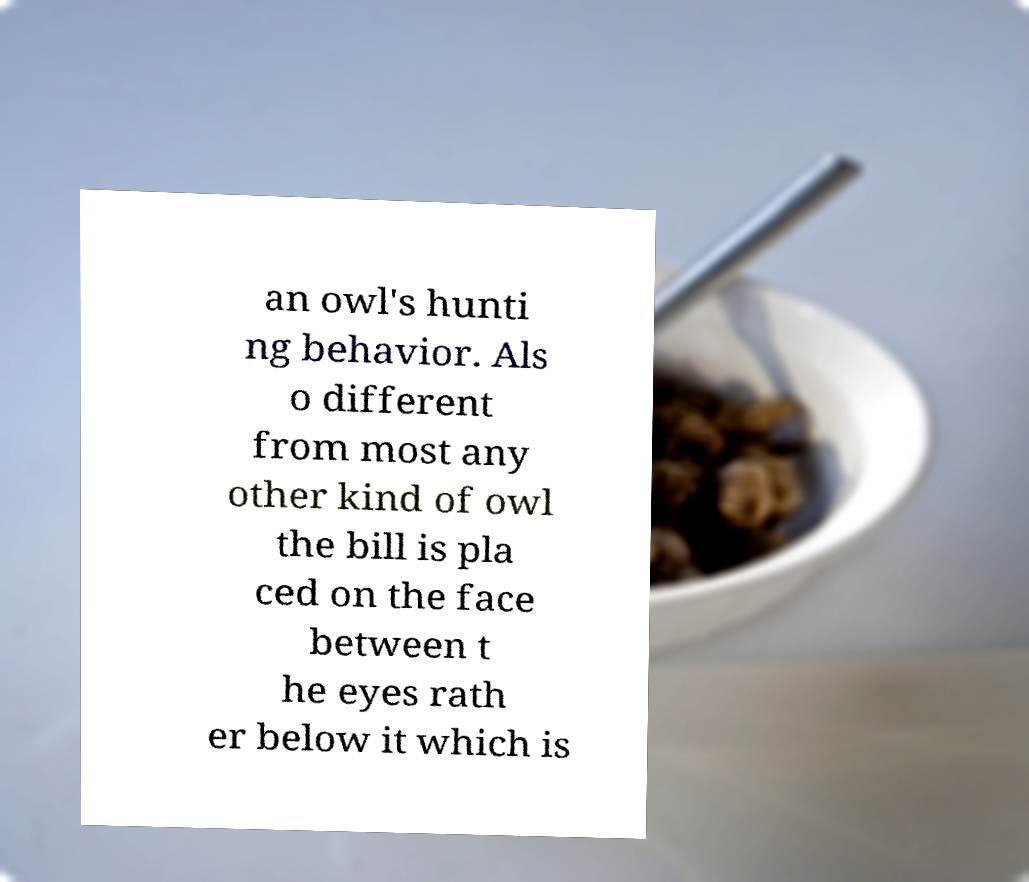Please read and relay the text visible in this image. What does it say? an owl's hunti ng behavior. Als o different from most any other kind of owl the bill is pla ced on the face between t he eyes rath er below it which is 